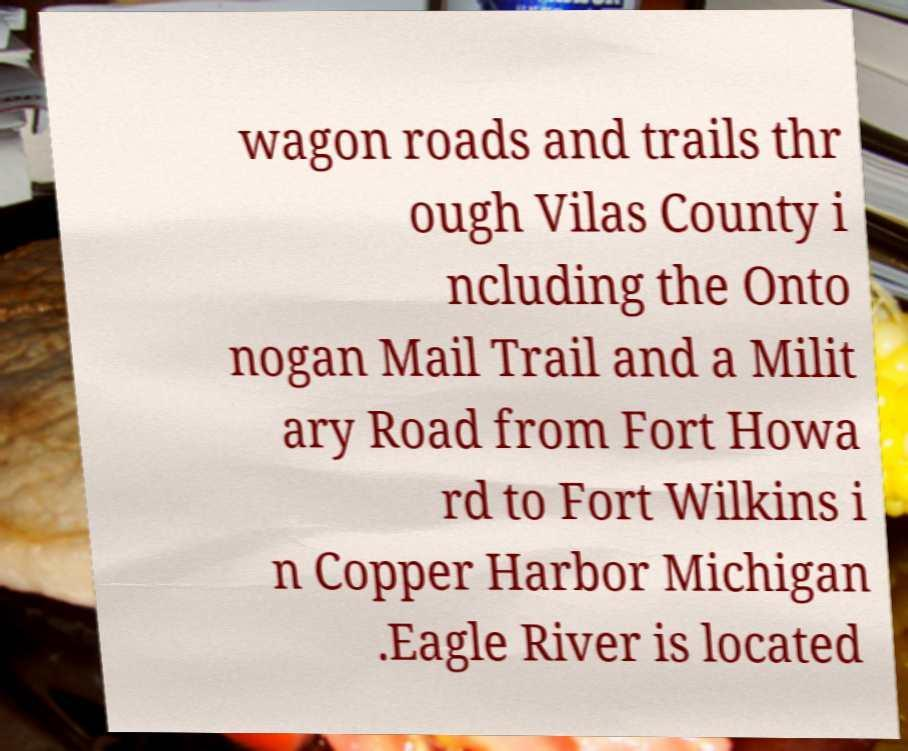Can you accurately transcribe the text from the provided image for me? wagon roads and trails thr ough Vilas County i ncluding the Onto nogan Mail Trail and a Milit ary Road from Fort Howa rd to Fort Wilkins i n Copper Harbor Michigan .Eagle River is located 